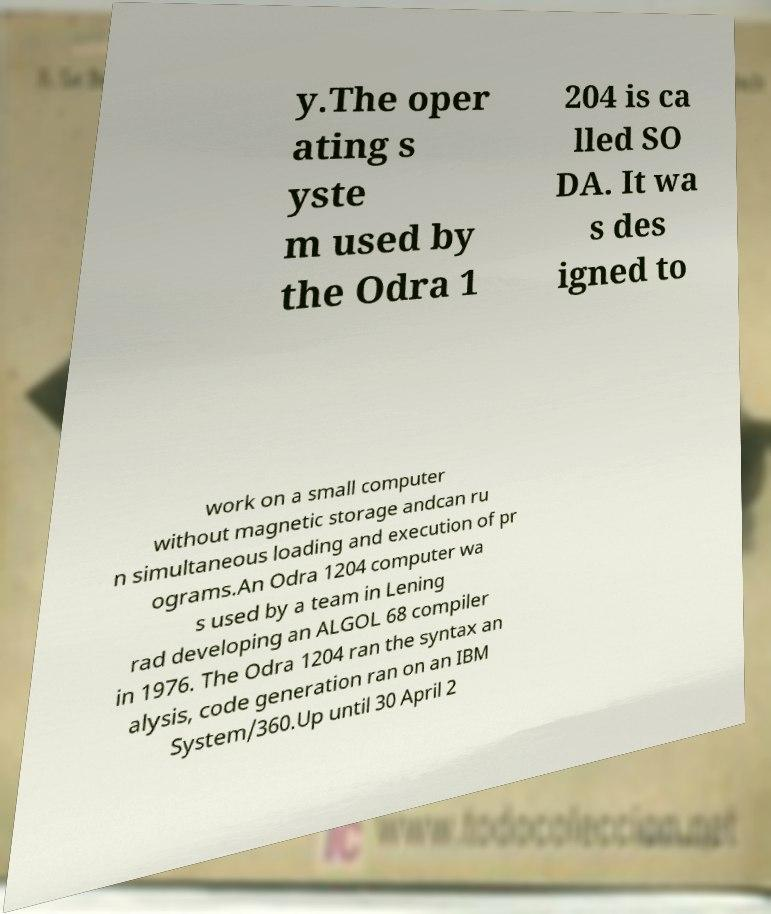Please identify and transcribe the text found in this image. y.The oper ating s yste m used by the Odra 1 204 is ca lled SO DA. It wa s des igned to work on a small computer without magnetic storage andcan ru n simultaneous loading and execution of pr ograms.An Odra 1204 computer wa s used by a team in Lening rad developing an ALGOL 68 compiler in 1976. The Odra 1204 ran the syntax an alysis, code generation ran on an IBM System/360.Up until 30 April 2 